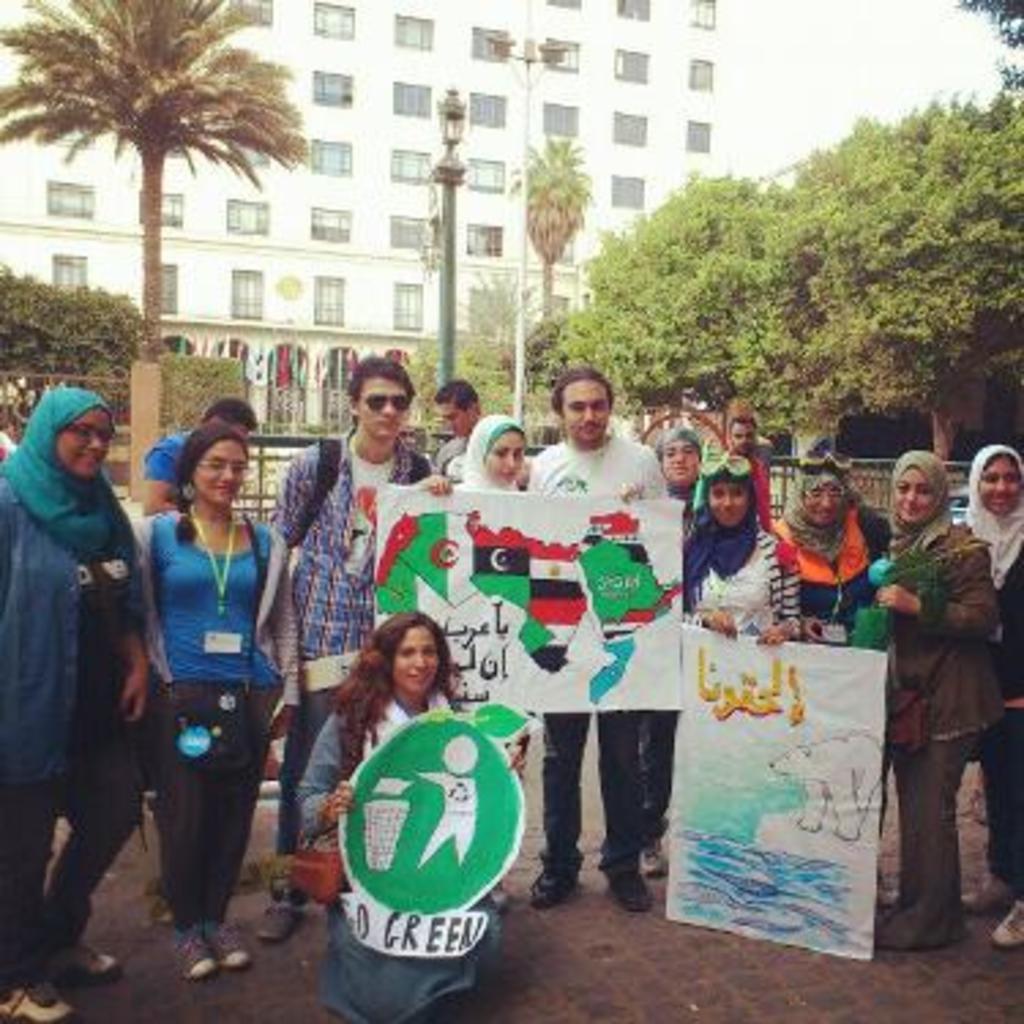In one or two sentences, can you explain what this image depicts? In this picture there is a group of man and woman standing on the cobbler stones and holding the whiteboard in the hands. Behind there are some trees and white color building with windows. 